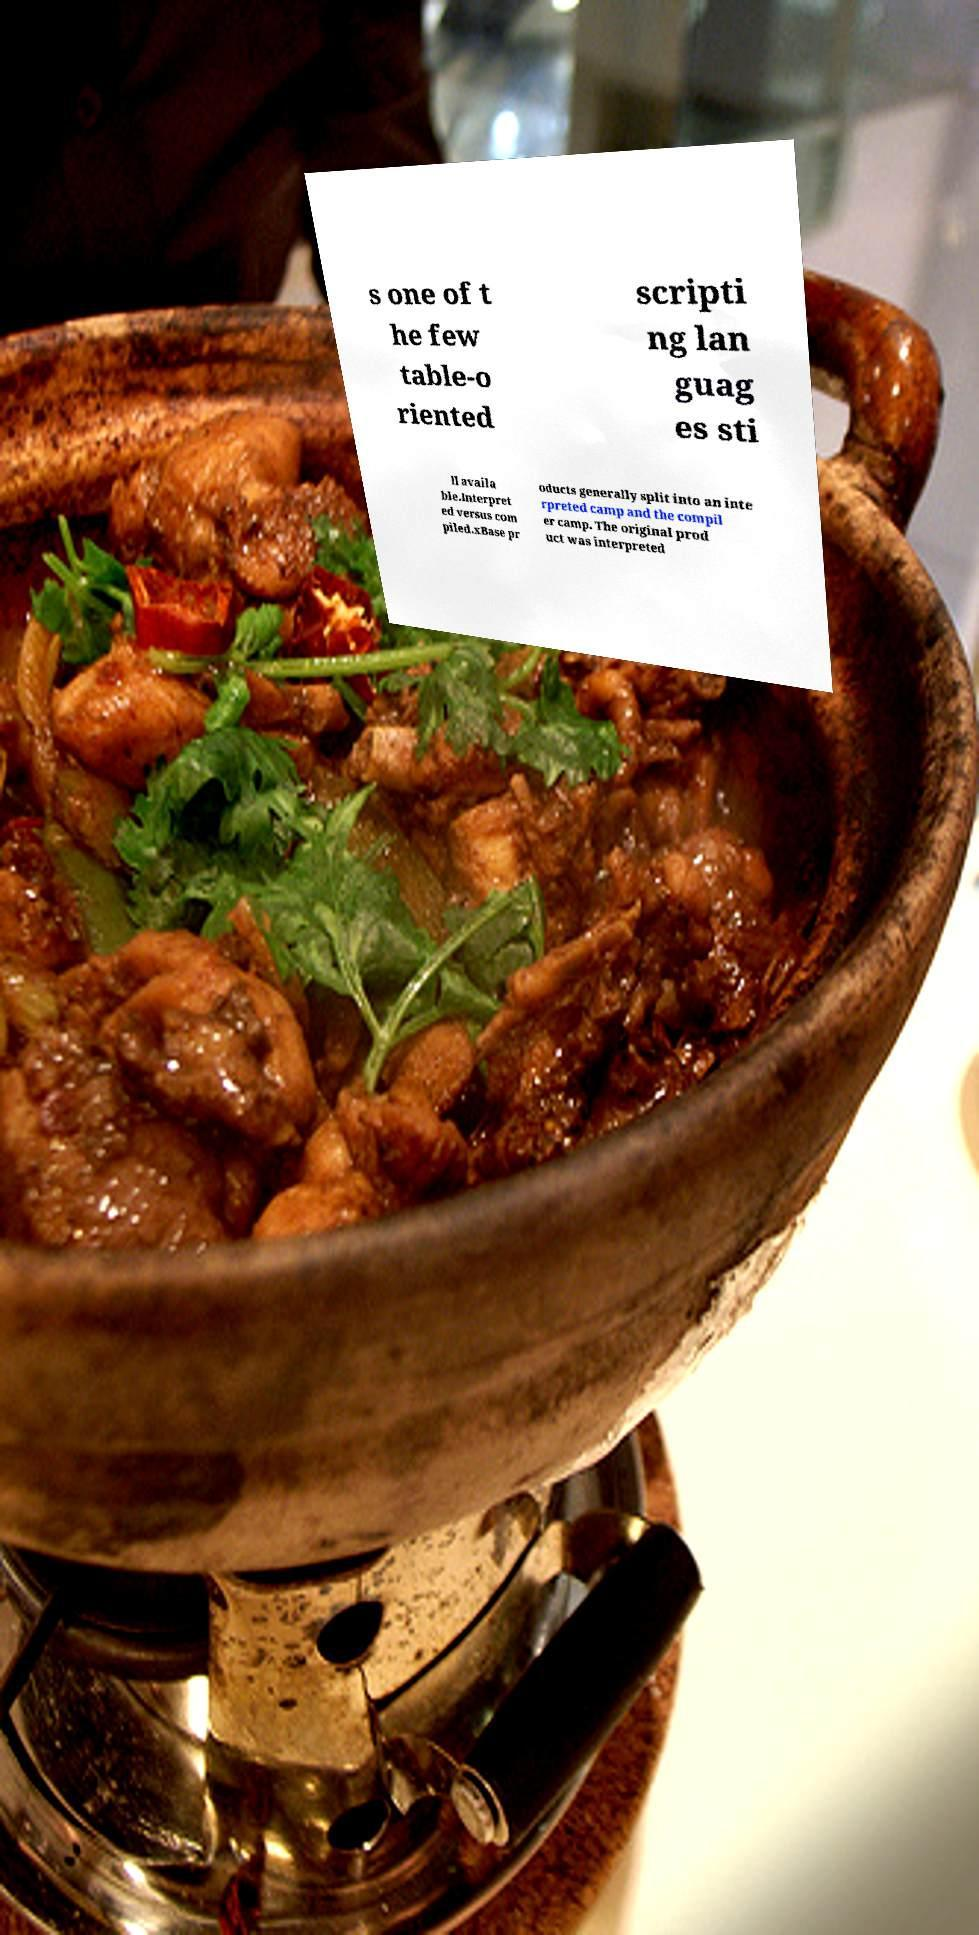For documentation purposes, I need the text within this image transcribed. Could you provide that? s one of t he few table-o riented scripti ng lan guag es sti ll availa ble.Interpret ed versus com piled.xBase pr oducts generally split into an inte rpreted camp and the compil er camp. The original prod uct was interpreted 